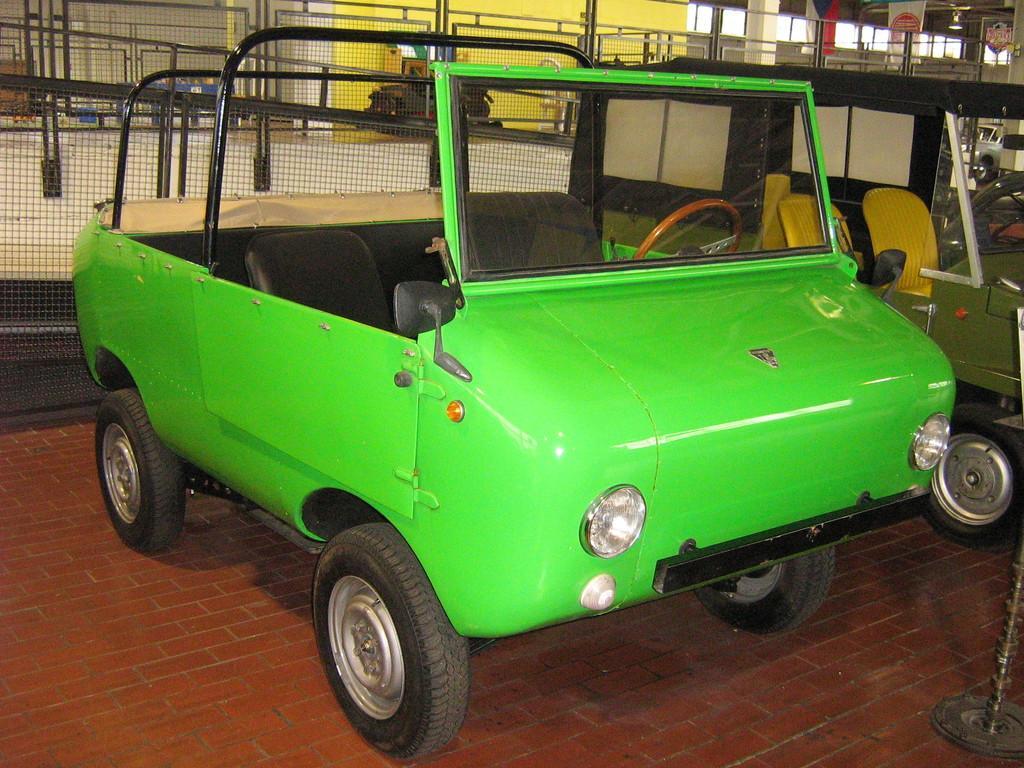Please provide a concise description of this image. In this image we can see two vehicles on the floor. In the background we can see the fence, railing, pillars, banners and also the wall. 